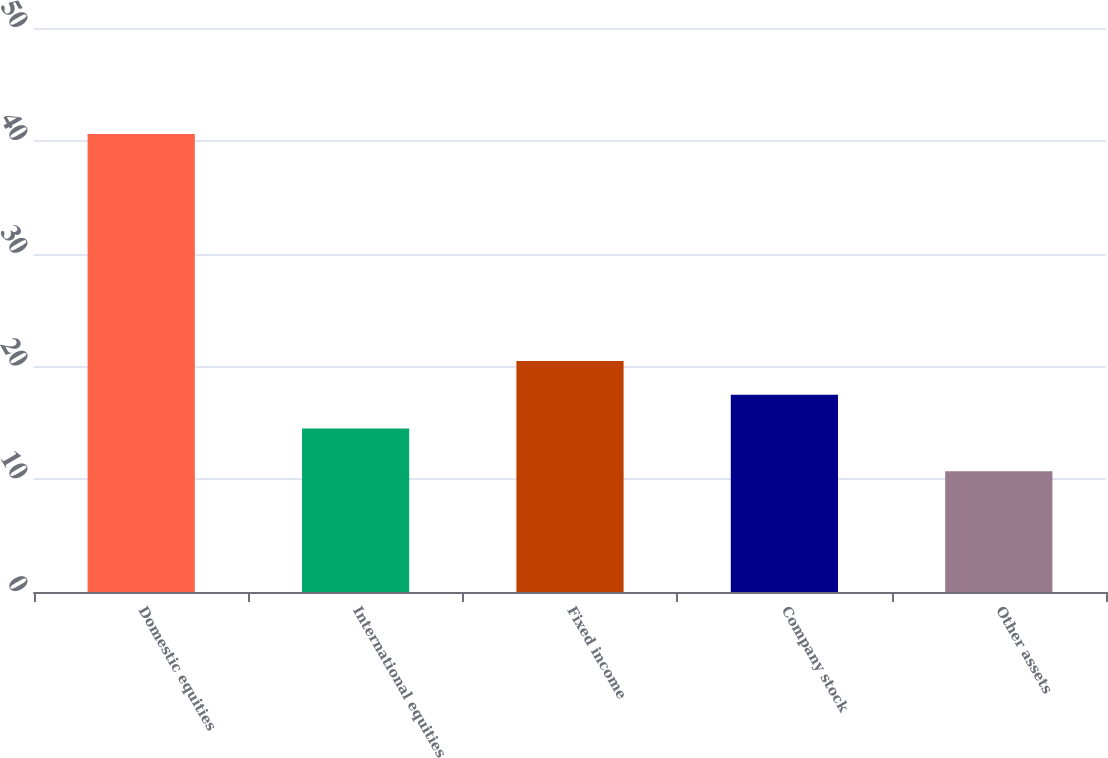<chart> <loc_0><loc_0><loc_500><loc_500><bar_chart><fcel>Domestic equities<fcel>International equities<fcel>Fixed income<fcel>Company stock<fcel>Other assets<nl><fcel>40.6<fcel>14.5<fcel>20.48<fcel>17.49<fcel>10.7<nl></chart> 